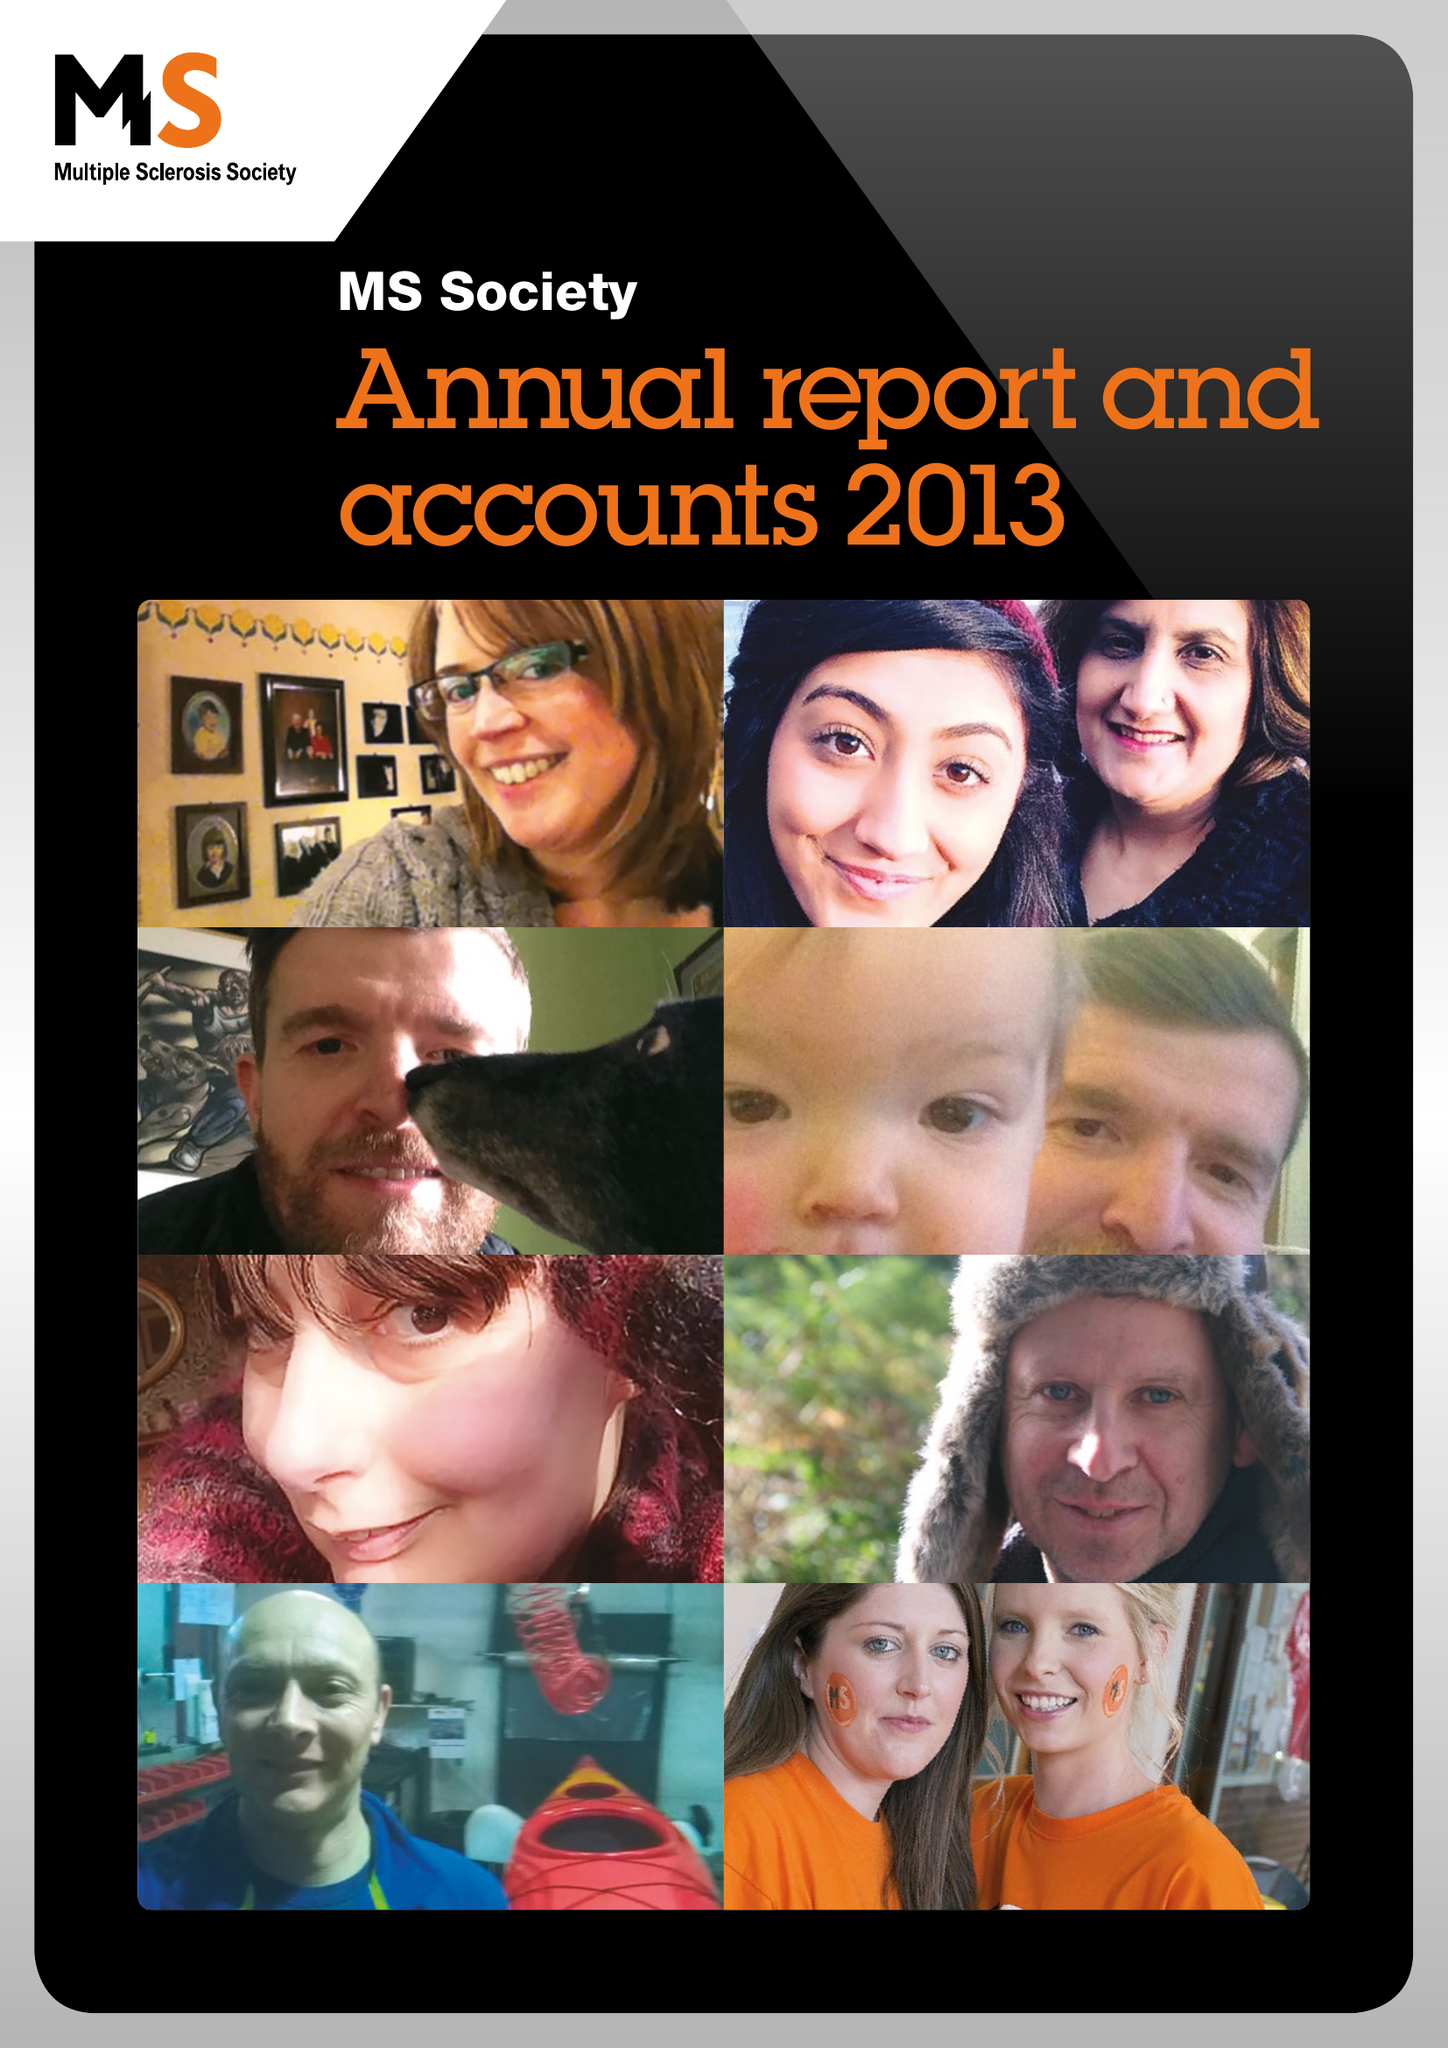What is the value for the address__postcode?
Answer the question using a single word or phrase. NW2 6ND 